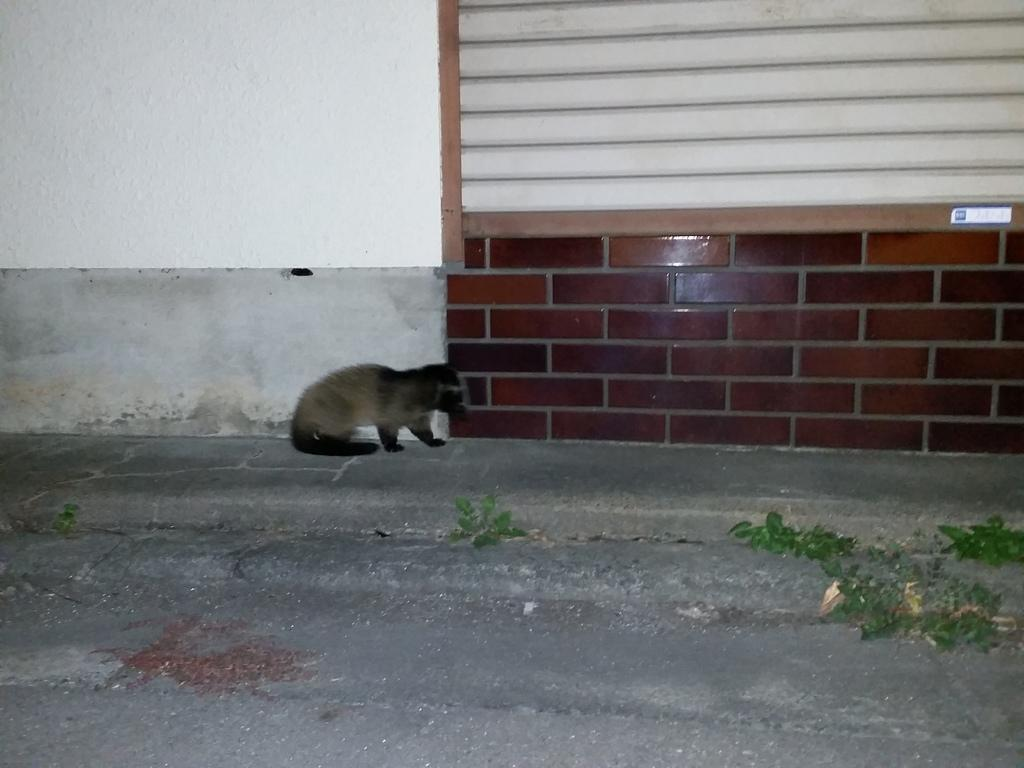What type of creature is in the image? There is an animal in the image. Where is the animal located? The animal is on the ground. What can be seen in the background of the image? There is a wall with ventilation in the background of the image. What type of grain is being controlled by the animal in the image? There is no grain present in the image, nor is there any indication that the animal is controlling anything. 